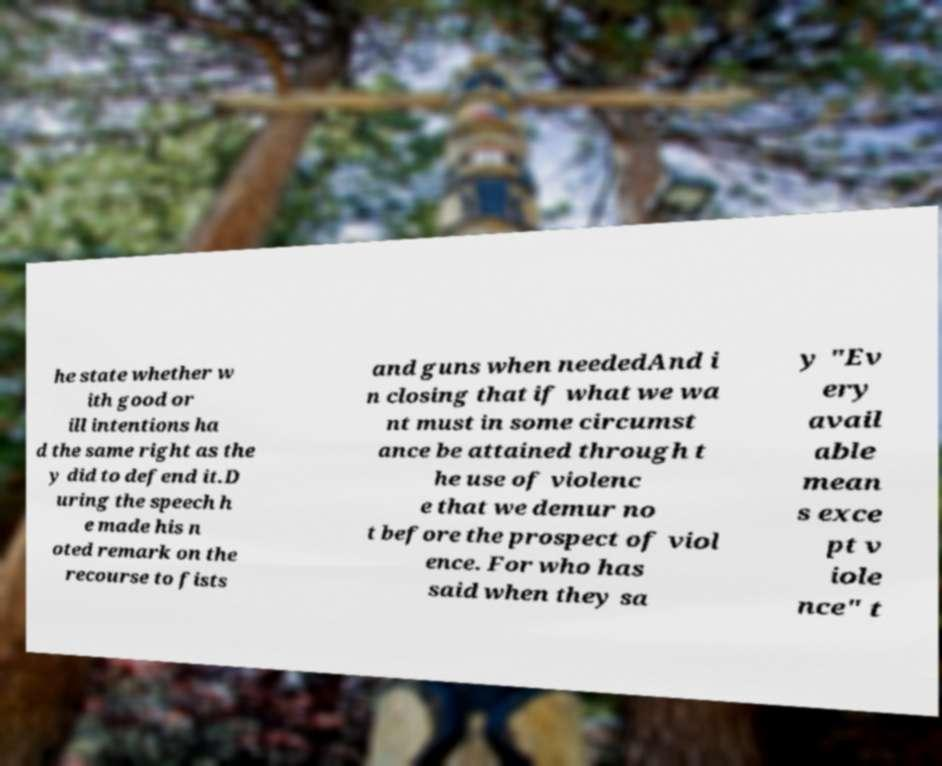Please read and relay the text visible in this image. What does it say? he state whether w ith good or ill intentions ha d the same right as the y did to defend it.D uring the speech h e made his n oted remark on the recourse to fists and guns when neededAnd i n closing that if what we wa nt must in some circumst ance be attained through t he use of violenc e that we demur no t before the prospect of viol ence. For who has said when they sa y "Ev ery avail able mean s exce pt v iole nce" t 